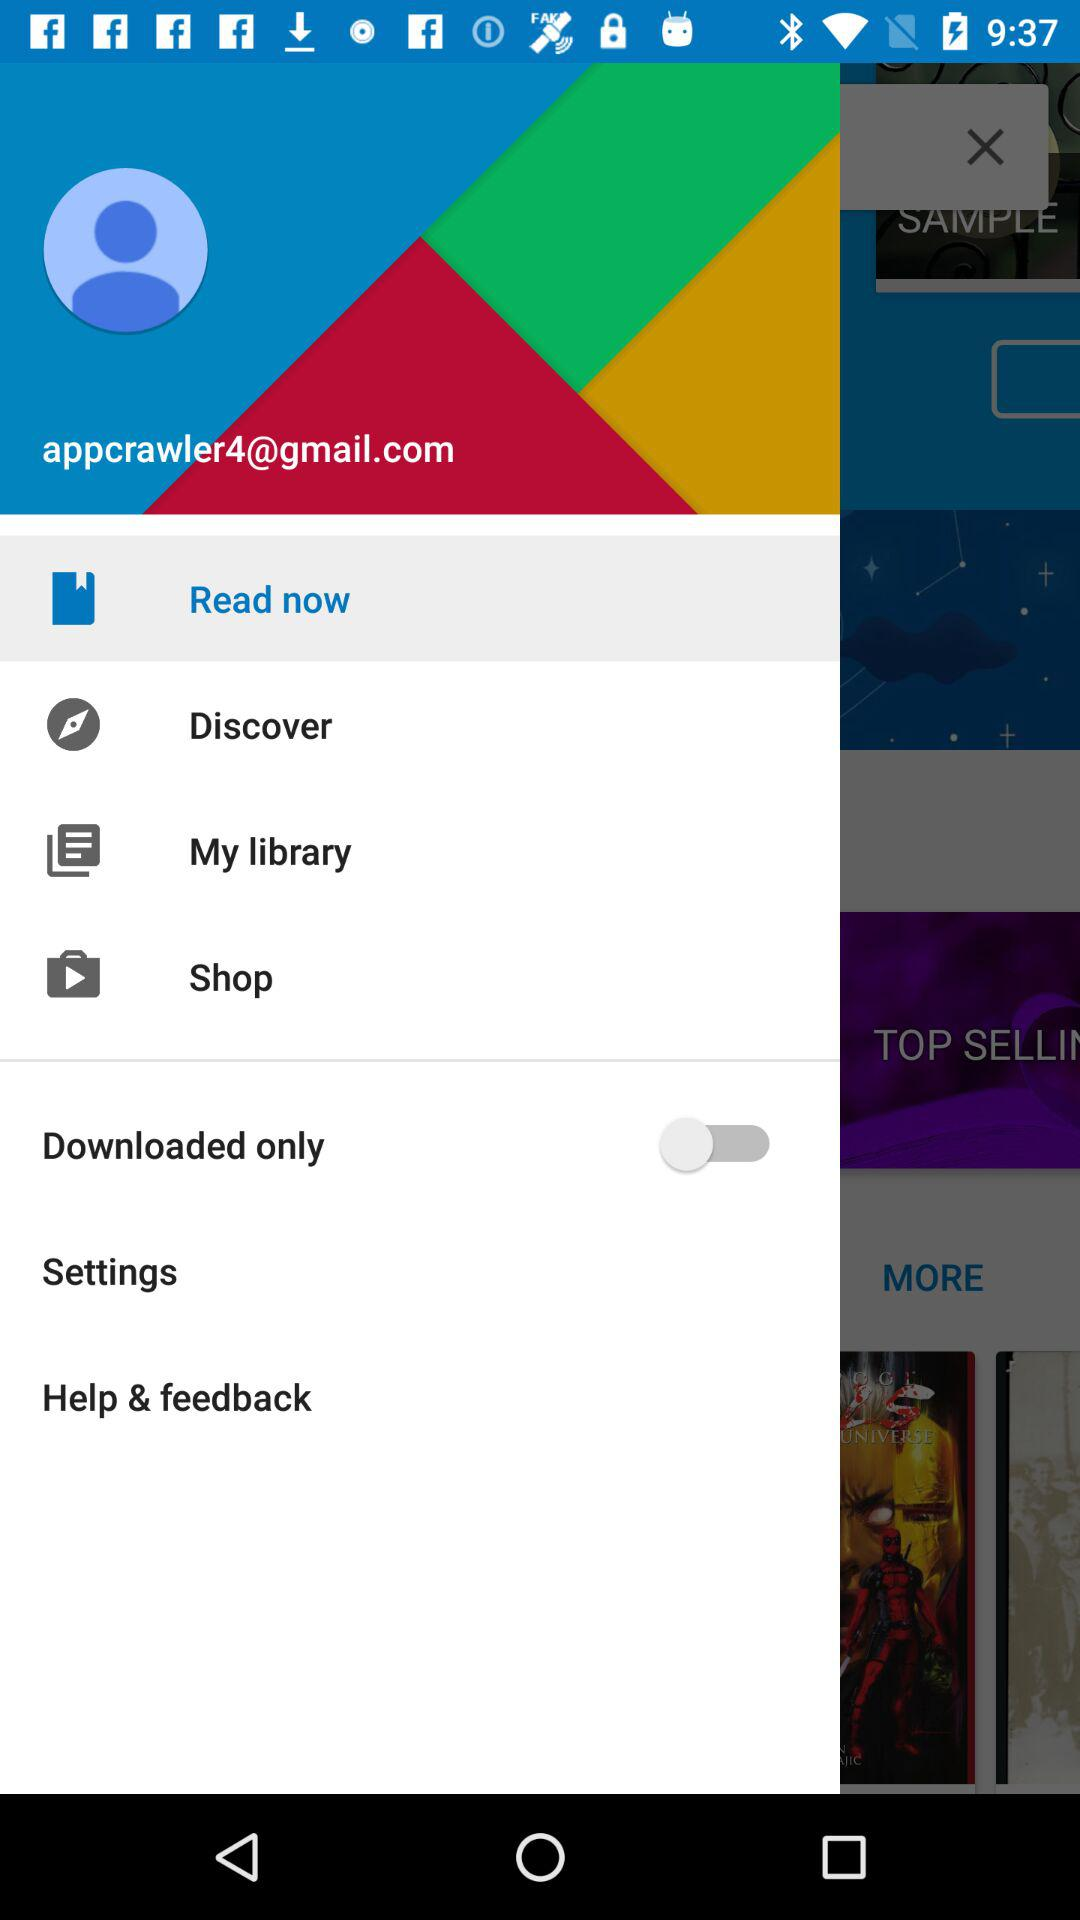What is the Gmail account address? The Gmail account address is appcrawler4@gmail.com. 